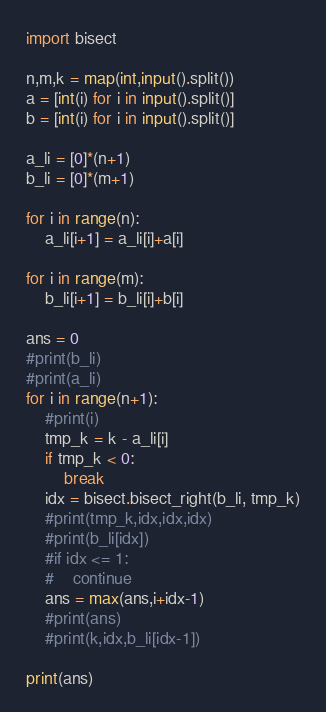Convert code to text. <code><loc_0><loc_0><loc_500><loc_500><_Python_>import bisect

n,m,k = map(int,input().split())
a = [int(i) for i in input().split()]
b = [int(i) for i in input().split()]

a_li = [0]*(n+1)
b_li = [0]*(m+1)

for i in range(n):
    a_li[i+1] = a_li[i]+a[i]
    
for i in range(m):
    b_li[i+1] = b_li[i]+b[i]

ans = 0
#print(b_li)
#print(a_li)
for i in range(n+1):
    #print(i)
    tmp_k = k - a_li[i]
    if tmp_k < 0:
        break
    idx = bisect.bisect_right(b_li, tmp_k)
    #print(tmp_k,idx,idx,idx)
    #print(b_li[idx])
    #if idx <= 1:
    #    continue
    ans = max(ans,i+idx-1)
    #print(ans)
    #print(k,idx,b_li[idx-1])
    
print(ans)</code> 